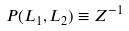<formula> <loc_0><loc_0><loc_500><loc_500>P ( L _ { 1 } , L _ { 2 } ) \equiv Z ^ { - 1 }</formula> 